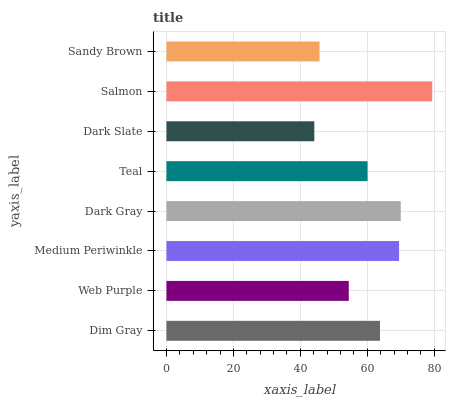Is Dark Slate the minimum?
Answer yes or no. Yes. Is Salmon the maximum?
Answer yes or no. Yes. Is Web Purple the minimum?
Answer yes or no. No. Is Web Purple the maximum?
Answer yes or no. No. Is Dim Gray greater than Web Purple?
Answer yes or no. Yes. Is Web Purple less than Dim Gray?
Answer yes or no. Yes. Is Web Purple greater than Dim Gray?
Answer yes or no. No. Is Dim Gray less than Web Purple?
Answer yes or no. No. Is Dim Gray the high median?
Answer yes or no. Yes. Is Teal the low median?
Answer yes or no. Yes. Is Medium Periwinkle the high median?
Answer yes or no. No. Is Salmon the low median?
Answer yes or no. No. 